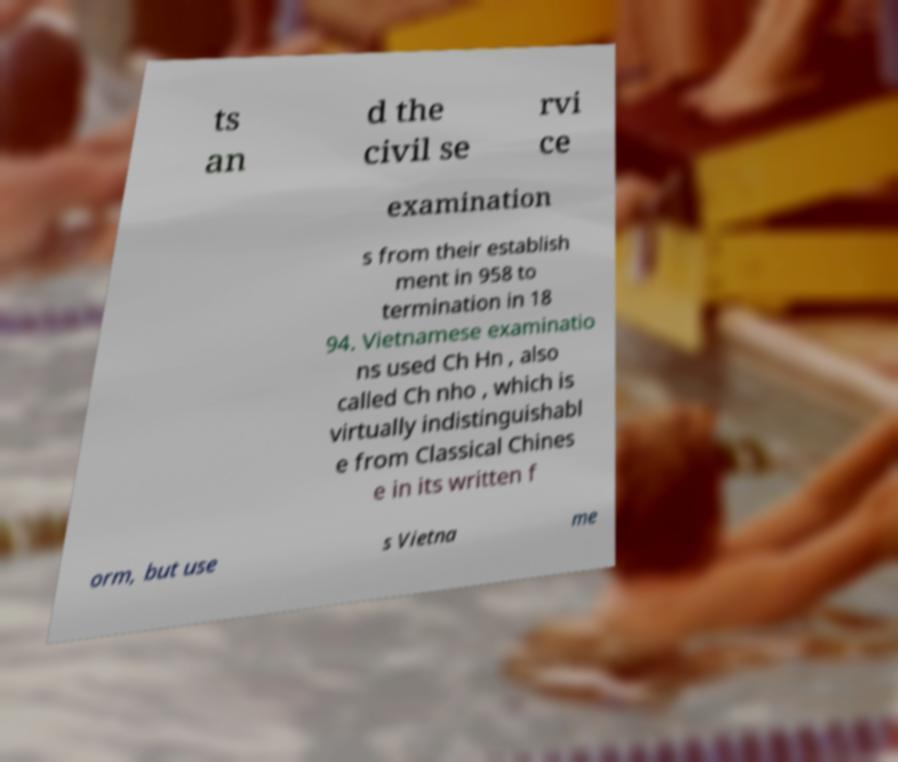Please identify and transcribe the text found in this image. ts an d the civil se rvi ce examination s from their establish ment in 958 to termination in 18 94. Vietnamese examinatio ns used Ch Hn , also called Ch nho , which is virtually indistinguishabl e from Classical Chines e in its written f orm, but use s Vietna me 